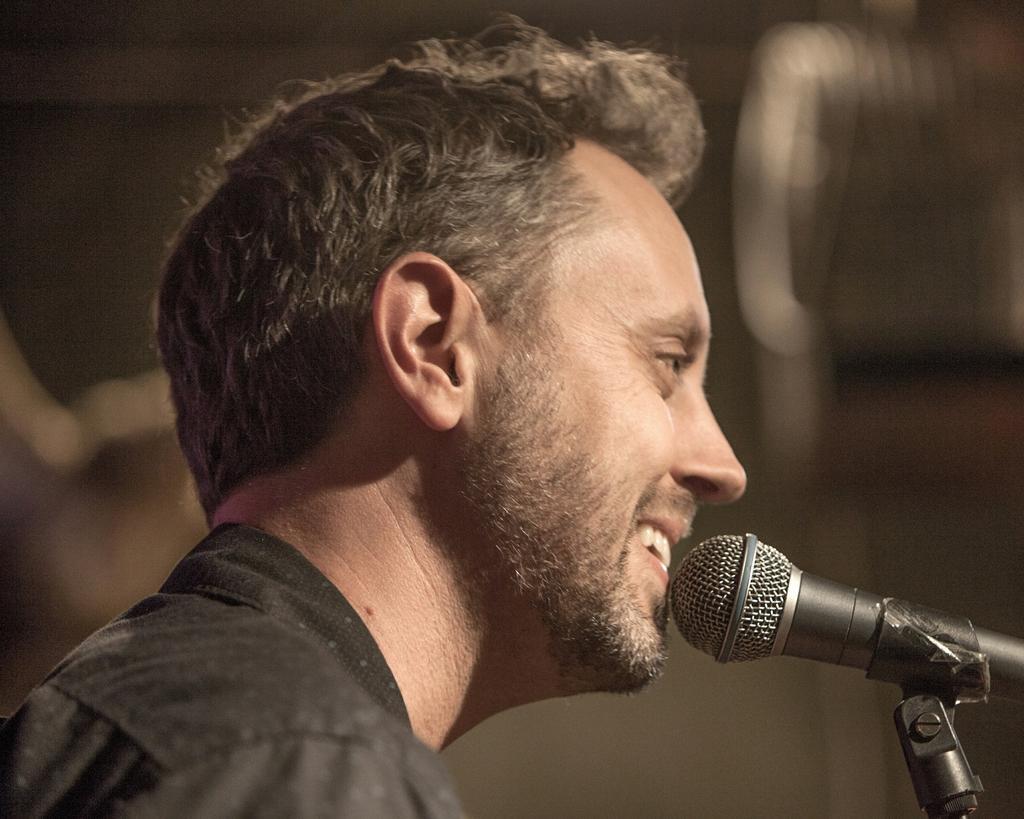Describe this image in one or two sentences. In this image the man is smiling. There is a mic. 